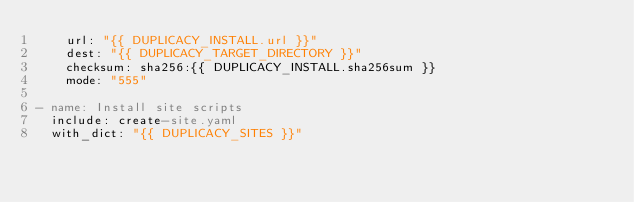Convert code to text. <code><loc_0><loc_0><loc_500><loc_500><_YAML_>    url: "{{ DUPLICACY_INSTALL.url }}"
    dest: "{{ DUPLICACY_TARGET_DIRECTORY }}"
    checksum: sha256:{{ DUPLICACY_INSTALL.sha256sum }}
    mode: "555"

- name: Install site scripts
  include: create-site.yaml
  with_dict: "{{ DUPLICACY_SITES }}"

</code> 